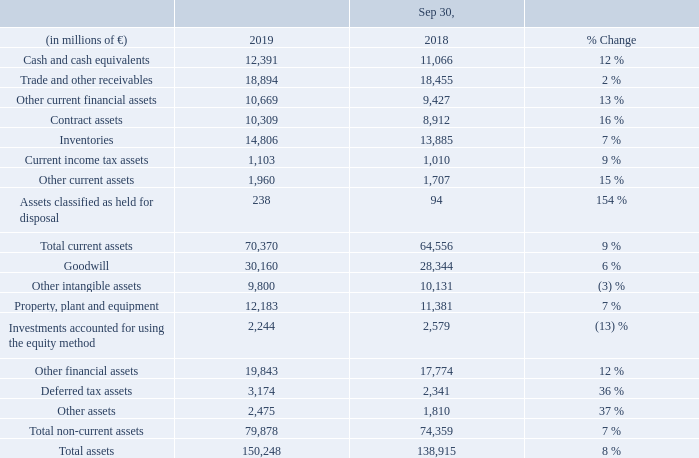A.5 Net assets position
Our total assets at the end of fiscal 2019 were influenced by positive currency translation effects of € 4.0 billion (mainly goodwill), primarily involving the U. S. dollar.
The increase in other current financial assets was driven by higher loans receivable at SFS, which were mainly due to new business and reclassification of non-current loans receivable from other financial assets. While higher loans receivable and receivables from finance leases from new business at SFS contributed also to growth in other financial assets, a large extent of the overall increase resulted from increased fair values of derivative financial instruments.
Inventories increased in several industrial businesses, with the build-up most evident at SGRE, Mobility and Siemens Healthineers.
Assets classified as held for disposal increased mainly due to reclassification of two investments from investments accounted for using the equity method.
The increase in goodwill included the acquisition of Mendix.
Deferred tax assets increased mainly due to income tax effects related to remeasurement of defined benefits plans.
The increase in other assets was driven mainly by higher net defined benefit assets from actuarial gains.
What caused the increase in the other financial assets? The increase in other current financial assets was driven by higher loans receivable at sfs, which were mainly due to new business and reclassification of non-current loans receivable from other financial assets. What caused the increase in the inventories? Inventories increased in several industrial businesses, with the build-up most evident at sgre, mobility and siemens healthineers. What caused the deferred tax assets to increase? Deferred tax assets increased mainly due to income tax effects related to remeasurement of defined benefits plans. What was the average inventories in 2019 and 2018?
Answer scale should be: million. (14,806 + 13,885) / 2
Answer: 14345.5. What is the increase / (decrease) in other current assets from 2018 to 2019?
Answer scale should be: million. 1,960 - 1,707
Answer: 253. What is the increase / (decrease) in total assets from 2018 to 2019?
Answer scale should be: million. 150,248 - 138,915
Answer: 11333. 